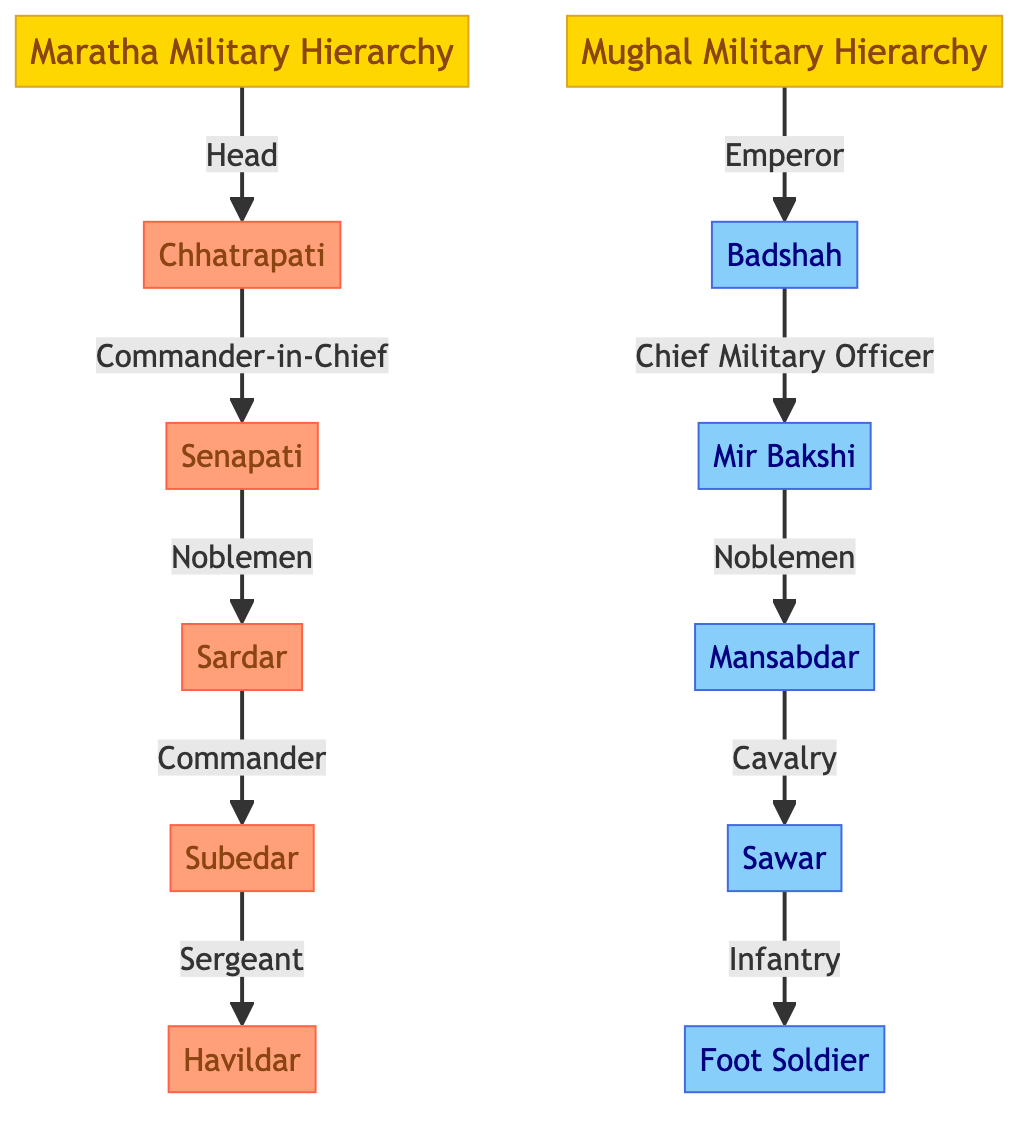What is the highest rank in the Maratha military hierarchy? The diagram shows that the highest rank in the Maratha military hierarchy is Chhatrapati, which is indicated as the head of the hierarchy.
Answer: Chhatrapati Who is the equivalent of the Senapati in the Mughal military hierarchy? In the Mughal military hierarchy, the equivalent position to the Senapati, who is a commander-in-chief in the Maratha structure, is Mir Bakshi, who acts as the chief military officer.
Answer: Mir Bakshi How many levels are in the Mughal military hierarchy? Upon examining the Mughal military hierarchy, we can see that it consists of five level positions: Badshah, Mir Bakshi, Mansabdar, Sawar, and Foot Soldier, making a total of five levels.
Answer: 5 What is the lowest rank in the Maratha military hierarchy? The lowest rank in the Maratha military hierarchy is Havildar, which is the final position listed below Subedar.
Answer: Havildar How many nodes are present in the Maratha military hierarchy? The Maratha military hierarchy consists of six nodes, which are Chhatrapati, Senapati, Sardar, Subedar, and Havildar. Counting all these gives a total of six nodes.
Answer: 6 Which position in Maratha commands the Subedar? In the hierarchy, the position that commands the Subedar is Sardar, as indicated by the "Commander" relationship connecting these two ranks.
Answer: Sardar What is the role of Mansabdar in the Mughal hierarchy? The Mansabdar serves as a noblemen in the Mughal hierarchy and is directly supported by the Mir Bakshi, making him a crucial link in the chain of command.
Answer: Noblemen What is the relationship between the Badshah and the Mir Bakshi in the Mughal hierarchy? In the Mughal military hierarchy, the Badshah, as the emperor, is the superior of the Mir Bakshi, who is identified as the chief military officer reporting directly to the Badshah.
Answer: Chief Military Officer What color represents the Maratha ranks in the diagram? The Maratha ranks are represented by an orange shade (#FFA07A) in the diagram, contrasting with the blue shade for Mughal ranks.
Answer: Orange 